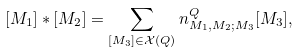Convert formula to latex. <formula><loc_0><loc_0><loc_500><loc_500>[ M _ { 1 } ] \ast [ M _ { 2 } ] = \sum _ { [ M _ { 3 } ] \in \mathcal { X } ( Q ) } n ^ { Q } _ { M _ { 1 } , M _ { 2 } ; M _ { 3 } } [ M _ { 3 } ] ,</formula> 